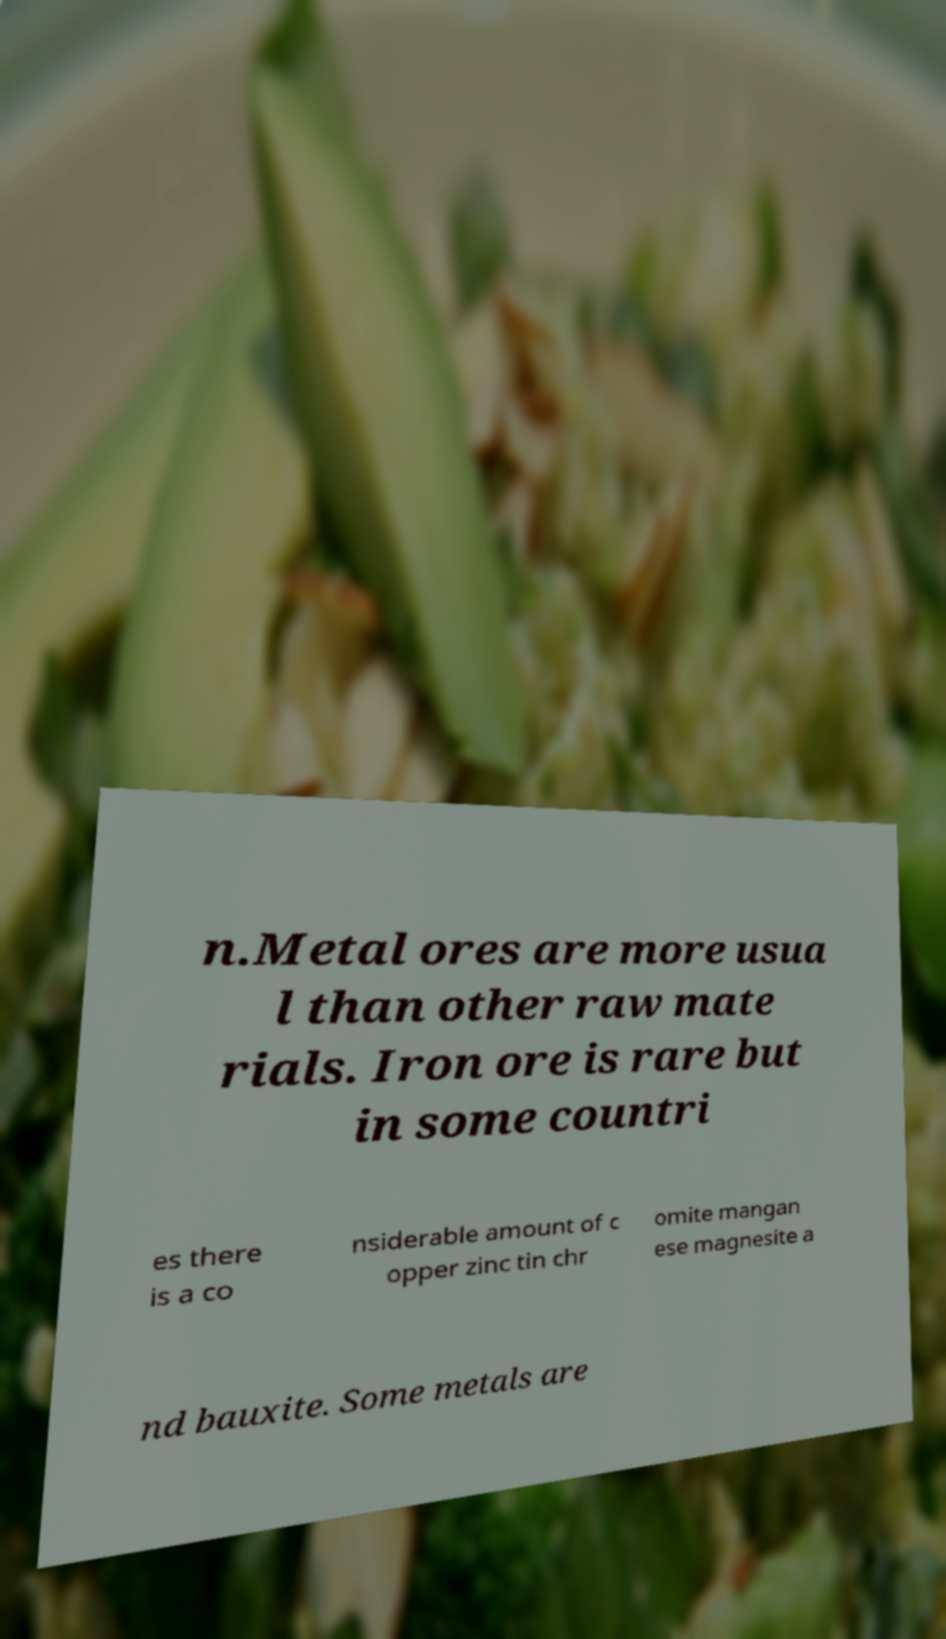Can you read and provide the text displayed in the image?This photo seems to have some interesting text. Can you extract and type it out for me? n.Metal ores are more usua l than other raw mate rials. Iron ore is rare but in some countri es there is a co nsiderable amount of c opper zinc tin chr omite mangan ese magnesite a nd bauxite. Some metals are 